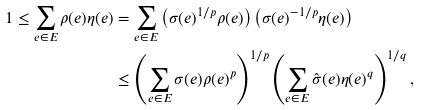<formula> <loc_0><loc_0><loc_500><loc_500>1 \leq \sum _ { e \in E } \rho ( e ) \eta ( e ) & = \sum _ { e \in E } \left ( \sigma ( e ) ^ { 1 / p } \rho ( e ) \right ) \left ( \sigma ( e ) ^ { - 1 / p } \eta ( e ) \right ) \\ & \leq \left ( \sum _ { e \in E } \sigma ( e ) \rho ( e ) ^ { p } \right ) ^ { 1 / p } \left ( \sum _ { e \in E } \hat { \sigma } ( e ) \eta ( e ) ^ { q } \right ) ^ { 1 / q } ,</formula> 